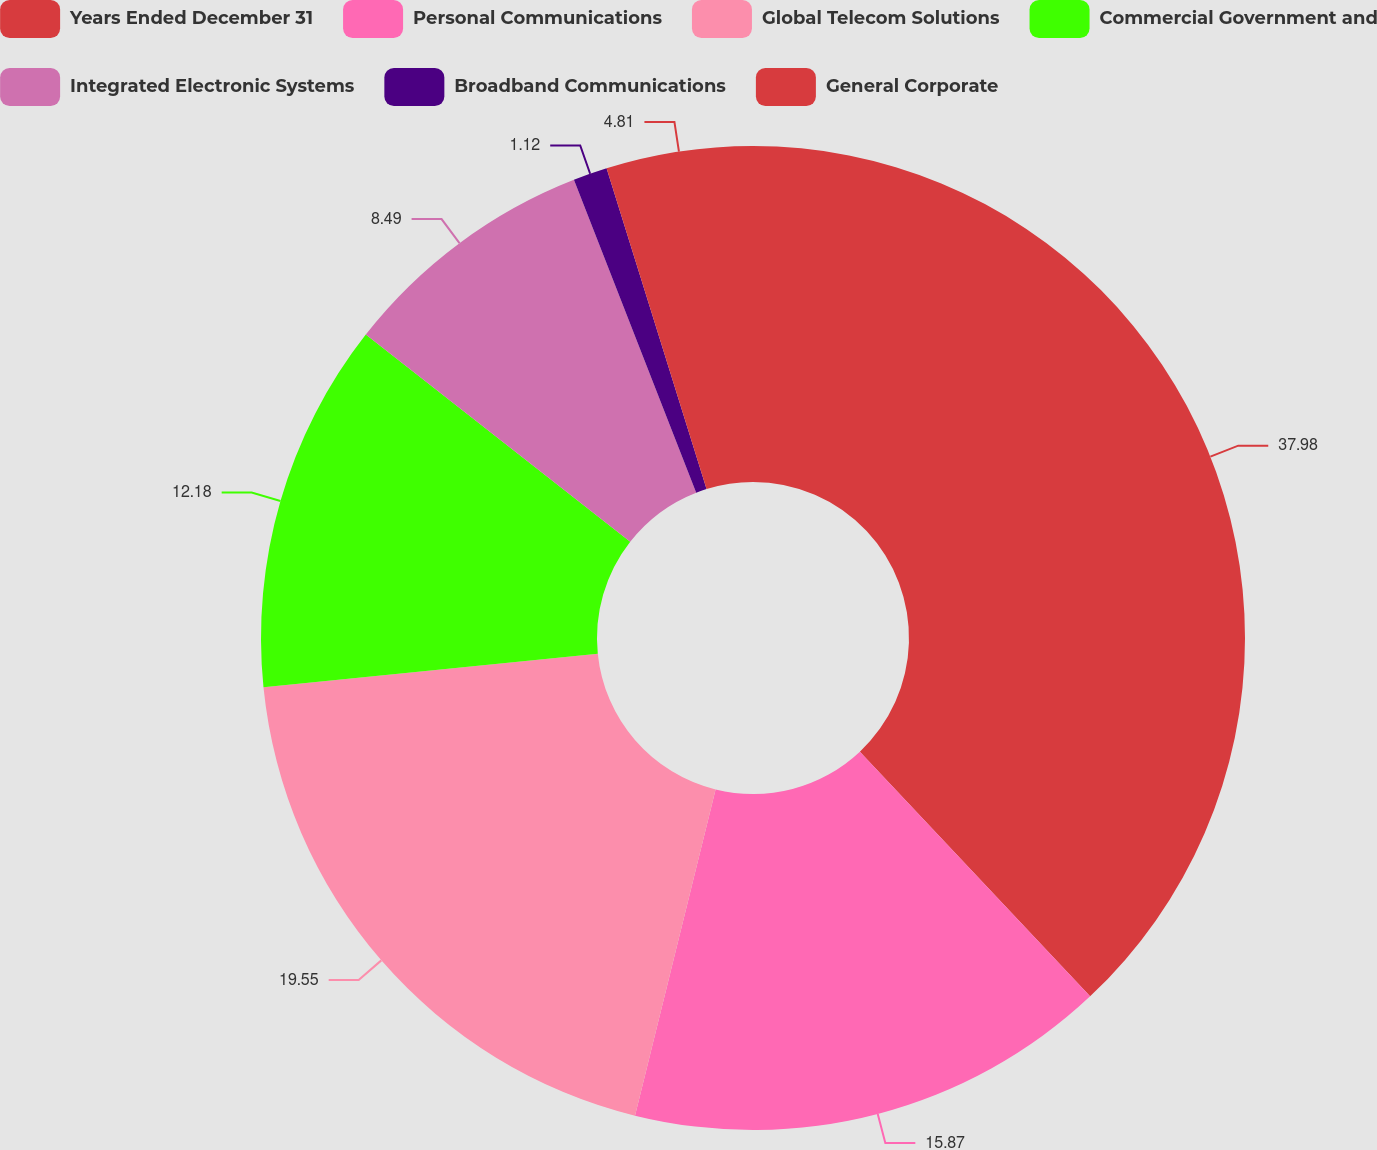Convert chart to OTSL. <chart><loc_0><loc_0><loc_500><loc_500><pie_chart><fcel>Years Ended December 31<fcel>Personal Communications<fcel>Global Telecom Solutions<fcel>Commercial Government and<fcel>Integrated Electronic Systems<fcel>Broadband Communications<fcel>General Corporate<nl><fcel>37.99%<fcel>15.87%<fcel>19.55%<fcel>12.18%<fcel>8.49%<fcel>1.12%<fcel>4.81%<nl></chart> 